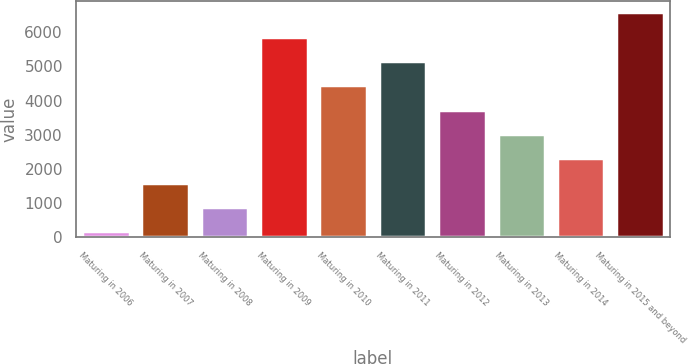<chart> <loc_0><loc_0><loc_500><loc_500><bar_chart><fcel>Maturing in 2006<fcel>Maturing in 2007<fcel>Maturing in 2008<fcel>Maturing in 2009<fcel>Maturing in 2010<fcel>Maturing in 2011<fcel>Maturing in 2012<fcel>Maturing in 2013<fcel>Maturing in 2014<fcel>Maturing in 2015 and beyond<nl><fcel>175<fcel>1600<fcel>887.5<fcel>5875<fcel>4450<fcel>5162.5<fcel>3737.5<fcel>3025<fcel>2312.5<fcel>6587.5<nl></chart> 